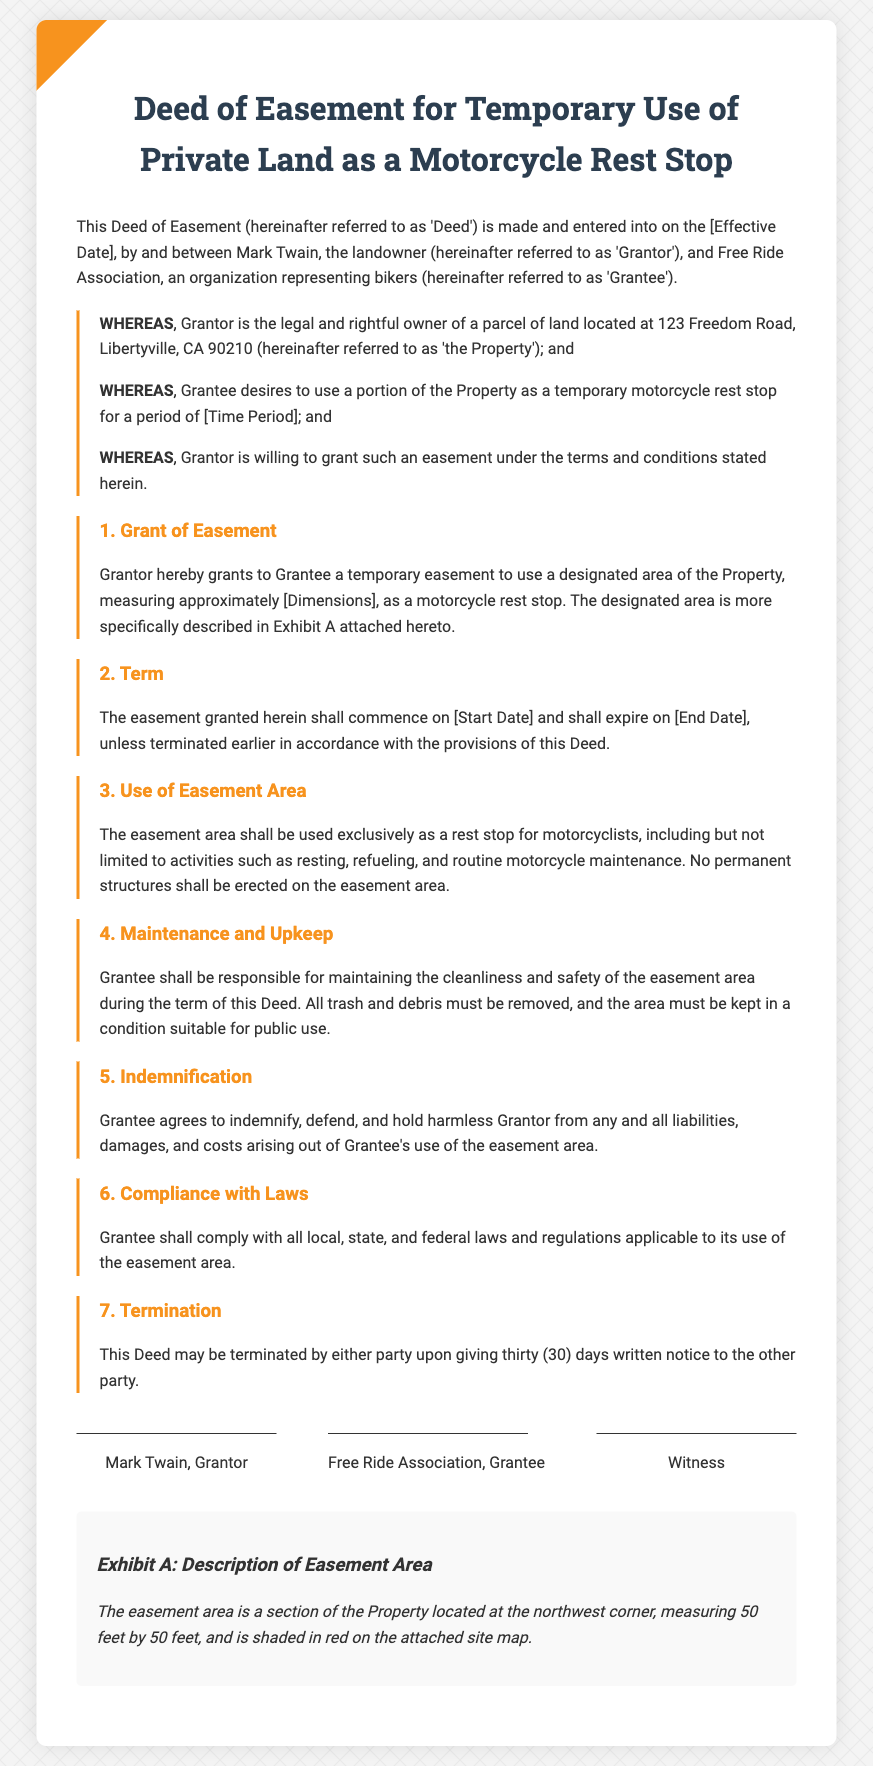What is the name of the Grantor? The Grantor is the individual who owns the property, which is Mark Twain as stated in the deed.
Answer: Mark Twain What is the address of the Property? The document specifies the legal location of the Property as 123 Freedom Road, Libertyville, CA 90210.
Answer: 123 Freedom Road, Libertyville, CA 90210 What are the dimensions of the easement area? The easement area is described with dimensions that are included in Exhibit A, which specifies a measurement of 50 feet by 50 feet.
Answer: 50 feet by 50 feet What is the effective date of the Deed? The effective date of the Deed is labeled as [Effective Date] in the introductory section, which is a placeholder needing specific information.
Answer: [Effective Date] Who is responsible for maintaining the easement area? The document explicitly states that the Grantee is responsible for maintaining the cleanliness and safety of the easement area during the term of the Deed.
Answer: Grantee How long does the easement last? According to the term section, the easement granted shall expire on [End Date], which is a placeholder.
Answer: [End Date] What activities are permitted in the easement area? The easement area shall be used exclusively for resting, refueling, and routine motorcycle maintenance as stated in the document.
Answer: Resting, refueling, and routine motorcycle maintenance What must be done to terminate the Deed? The Deed may be terminated by giving thirty (30) days written notice, which is outlined in the termination section.
Answer: Thirty (30) days written notice What organization does the Grantee represent? The Grantee represents an organization related to bikers known as the Free Ride Association, as stated in the introductory paragraph.
Answer: Free Ride Association 